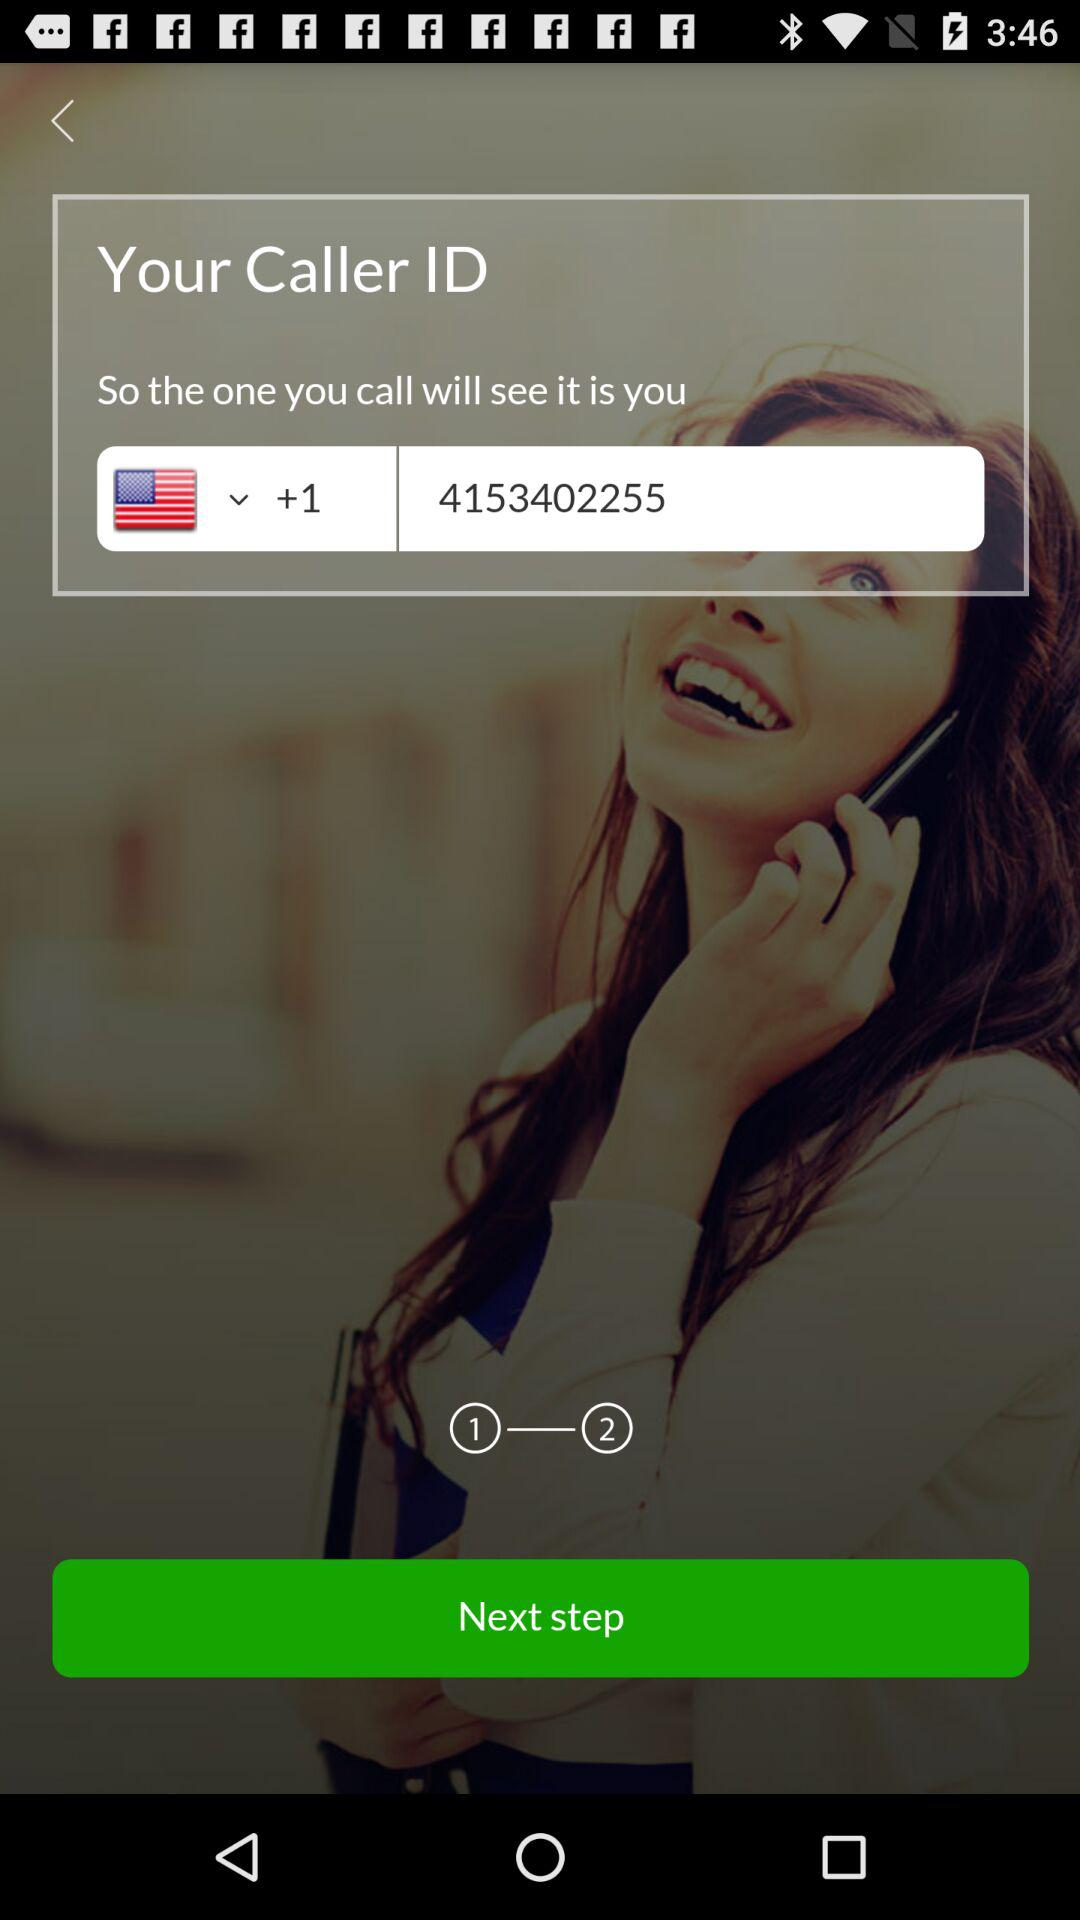How many digits are in the phone number?
Answer the question using a single word or phrase. 10 